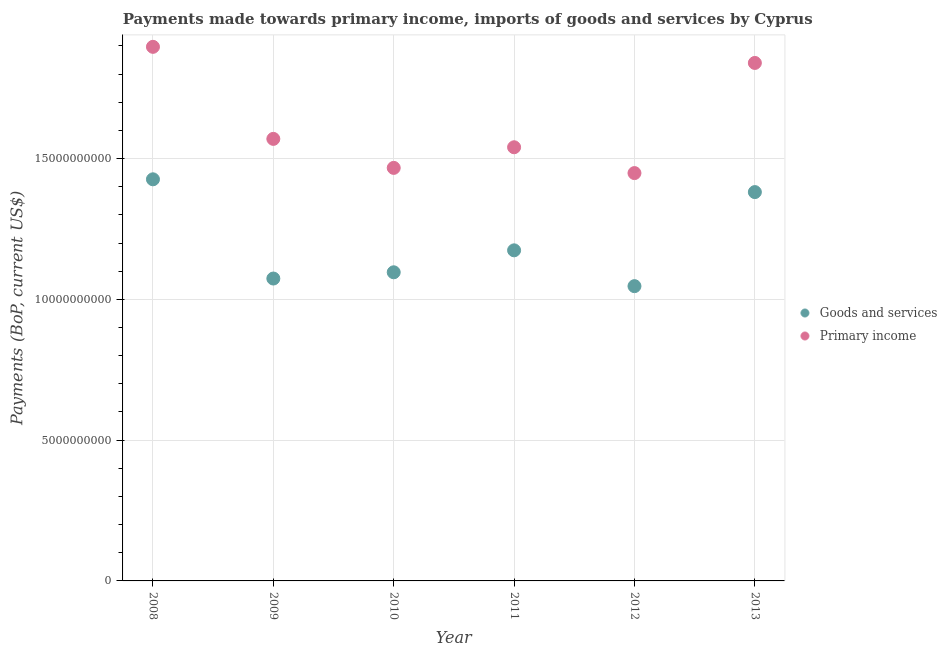How many different coloured dotlines are there?
Ensure brevity in your answer.  2. Is the number of dotlines equal to the number of legend labels?
Your response must be concise. Yes. What is the payments made towards goods and services in 2008?
Offer a terse response. 1.43e+1. Across all years, what is the maximum payments made towards goods and services?
Make the answer very short. 1.43e+1. Across all years, what is the minimum payments made towards goods and services?
Give a very brief answer. 1.05e+1. What is the total payments made towards goods and services in the graph?
Your answer should be compact. 7.20e+1. What is the difference between the payments made towards primary income in 2010 and that in 2012?
Ensure brevity in your answer.  1.85e+08. What is the difference between the payments made towards goods and services in 2010 and the payments made towards primary income in 2012?
Ensure brevity in your answer.  -3.52e+09. What is the average payments made towards goods and services per year?
Offer a very short reply. 1.20e+1. In the year 2010, what is the difference between the payments made towards goods and services and payments made towards primary income?
Offer a terse response. -3.71e+09. In how many years, is the payments made towards primary income greater than 18000000000 US$?
Offer a terse response. 2. What is the ratio of the payments made towards goods and services in 2011 to that in 2013?
Provide a short and direct response. 0.85. Is the payments made towards goods and services in 2008 less than that in 2011?
Offer a terse response. No. What is the difference between the highest and the second highest payments made towards primary income?
Provide a succinct answer. 5.72e+08. What is the difference between the highest and the lowest payments made towards goods and services?
Offer a very short reply. 3.79e+09. In how many years, is the payments made towards goods and services greater than the average payments made towards goods and services taken over all years?
Provide a succinct answer. 2. Is the payments made towards primary income strictly greater than the payments made towards goods and services over the years?
Make the answer very short. Yes. What is the difference between two consecutive major ticks on the Y-axis?
Offer a terse response. 5.00e+09. Are the values on the major ticks of Y-axis written in scientific E-notation?
Your answer should be very brief. No. Where does the legend appear in the graph?
Your response must be concise. Center right. How many legend labels are there?
Make the answer very short. 2. How are the legend labels stacked?
Your response must be concise. Vertical. What is the title of the graph?
Your response must be concise. Payments made towards primary income, imports of goods and services by Cyprus. What is the label or title of the Y-axis?
Ensure brevity in your answer.  Payments (BoP, current US$). What is the Payments (BoP, current US$) of Goods and services in 2008?
Give a very brief answer. 1.43e+1. What is the Payments (BoP, current US$) in Primary income in 2008?
Keep it short and to the point. 1.90e+1. What is the Payments (BoP, current US$) in Goods and services in 2009?
Give a very brief answer. 1.07e+1. What is the Payments (BoP, current US$) in Primary income in 2009?
Make the answer very short. 1.57e+1. What is the Payments (BoP, current US$) of Goods and services in 2010?
Offer a very short reply. 1.10e+1. What is the Payments (BoP, current US$) of Primary income in 2010?
Ensure brevity in your answer.  1.47e+1. What is the Payments (BoP, current US$) of Goods and services in 2011?
Your response must be concise. 1.17e+1. What is the Payments (BoP, current US$) of Primary income in 2011?
Keep it short and to the point. 1.54e+1. What is the Payments (BoP, current US$) of Goods and services in 2012?
Give a very brief answer. 1.05e+1. What is the Payments (BoP, current US$) in Primary income in 2012?
Offer a terse response. 1.45e+1. What is the Payments (BoP, current US$) in Goods and services in 2013?
Provide a succinct answer. 1.38e+1. What is the Payments (BoP, current US$) of Primary income in 2013?
Your answer should be compact. 1.84e+1. Across all years, what is the maximum Payments (BoP, current US$) in Goods and services?
Ensure brevity in your answer.  1.43e+1. Across all years, what is the maximum Payments (BoP, current US$) of Primary income?
Provide a short and direct response. 1.90e+1. Across all years, what is the minimum Payments (BoP, current US$) of Goods and services?
Offer a terse response. 1.05e+1. Across all years, what is the minimum Payments (BoP, current US$) in Primary income?
Your response must be concise. 1.45e+1. What is the total Payments (BoP, current US$) in Goods and services in the graph?
Your response must be concise. 7.20e+1. What is the total Payments (BoP, current US$) in Primary income in the graph?
Your answer should be compact. 9.76e+1. What is the difference between the Payments (BoP, current US$) in Goods and services in 2008 and that in 2009?
Give a very brief answer. 3.52e+09. What is the difference between the Payments (BoP, current US$) in Primary income in 2008 and that in 2009?
Your answer should be very brief. 3.27e+09. What is the difference between the Payments (BoP, current US$) in Goods and services in 2008 and that in 2010?
Provide a succinct answer. 3.30e+09. What is the difference between the Payments (BoP, current US$) in Primary income in 2008 and that in 2010?
Offer a very short reply. 4.30e+09. What is the difference between the Payments (BoP, current US$) of Goods and services in 2008 and that in 2011?
Your response must be concise. 2.52e+09. What is the difference between the Payments (BoP, current US$) of Primary income in 2008 and that in 2011?
Offer a terse response. 3.57e+09. What is the difference between the Payments (BoP, current US$) in Goods and services in 2008 and that in 2012?
Provide a short and direct response. 3.79e+09. What is the difference between the Payments (BoP, current US$) in Primary income in 2008 and that in 2012?
Your answer should be very brief. 4.48e+09. What is the difference between the Payments (BoP, current US$) in Goods and services in 2008 and that in 2013?
Keep it short and to the point. 4.54e+08. What is the difference between the Payments (BoP, current US$) of Primary income in 2008 and that in 2013?
Make the answer very short. 5.72e+08. What is the difference between the Payments (BoP, current US$) of Goods and services in 2009 and that in 2010?
Your answer should be compact. -2.22e+08. What is the difference between the Payments (BoP, current US$) of Primary income in 2009 and that in 2010?
Give a very brief answer. 1.03e+09. What is the difference between the Payments (BoP, current US$) of Goods and services in 2009 and that in 2011?
Give a very brief answer. -1.00e+09. What is the difference between the Payments (BoP, current US$) in Primary income in 2009 and that in 2011?
Offer a terse response. 2.97e+08. What is the difference between the Payments (BoP, current US$) in Goods and services in 2009 and that in 2012?
Your answer should be compact. 2.70e+08. What is the difference between the Payments (BoP, current US$) in Primary income in 2009 and that in 2012?
Offer a terse response. 1.21e+09. What is the difference between the Payments (BoP, current US$) of Goods and services in 2009 and that in 2013?
Provide a succinct answer. -3.07e+09. What is the difference between the Payments (BoP, current US$) of Primary income in 2009 and that in 2013?
Provide a short and direct response. -2.70e+09. What is the difference between the Payments (BoP, current US$) in Goods and services in 2010 and that in 2011?
Keep it short and to the point. -7.80e+08. What is the difference between the Payments (BoP, current US$) of Primary income in 2010 and that in 2011?
Make the answer very short. -7.33e+08. What is the difference between the Payments (BoP, current US$) in Goods and services in 2010 and that in 2012?
Keep it short and to the point. 4.92e+08. What is the difference between the Payments (BoP, current US$) in Primary income in 2010 and that in 2012?
Provide a short and direct response. 1.85e+08. What is the difference between the Payments (BoP, current US$) in Goods and services in 2010 and that in 2013?
Your response must be concise. -2.85e+09. What is the difference between the Payments (BoP, current US$) in Primary income in 2010 and that in 2013?
Ensure brevity in your answer.  -3.73e+09. What is the difference between the Payments (BoP, current US$) of Goods and services in 2011 and that in 2012?
Give a very brief answer. 1.27e+09. What is the difference between the Payments (BoP, current US$) in Primary income in 2011 and that in 2012?
Offer a very short reply. 9.17e+08. What is the difference between the Payments (BoP, current US$) of Goods and services in 2011 and that in 2013?
Ensure brevity in your answer.  -2.07e+09. What is the difference between the Payments (BoP, current US$) in Primary income in 2011 and that in 2013?
Your answer should be compact. -2.99e+09. What is the difference between the Payments (BoP, current US$) in Goods and services in 2012 and that in 2013?
Offer a very short reply. -3.34e+09. What is the difference between the Payments (BoP, current US$) of Primary income in 2012 and that in 2013?
Provide a succinct answer. -3.91e+09. What is the difference between the Payments (BoP, current US$) of Goods and services in 2008 and the Payments (BoP, current US$) of Primary income in 2009?
Your answer should be very brief. -1.44e+09. What is the difference between the Payments (BoP, current US$) in Goods and services in 2008 and the Payments (BoP, current US$) in Primary income in 2010?
Provide a succinct answer. -4.06e+08. What is the difference between the Payments (BoP, current US$) of Goods and services in 2008 and the Payments (BoP, current US$) of Primary income in 2011?
Your answer should be very brief. -1.14e+09. What is the difference between the Payments (BoP, current US$) of Goods and services in 2008 and the Payments (BoP, current US$) of Primary income in 2012?
Your response must be concise. -2.21e+08. What is the difference between the Payments (BoP, current US$) of Goods and services in 2008 and the Payments (BoP, current US$) of Primary income in 2013?
Offer a terse response. -4.13e+09. What is the difference between the Payments (BoP, current US$) in Goods and services in 2009 and the Payments (BoP, current US$) in Primary income in 2010?
Give a very brief answer. -3.93e+09. What is the difference between the Payments (BoP, current US$) of Goods and services in 2009 and the Payments (BoP, current US$) of Primary income in 2011?
Offer a terse response. -4.66e+09. What is the difference between the Payments (BoP, current US$) of Goods and services in 2009 and the Payments (BoP, current US$) of Primary income in 2012?
Keep it short and to the point. -3.75e+09. What is the difference between the Payments (BoP, current US$) in Goods and services in 2009 and the Payments (BoP, current US$) in Primary income in 2013?
Provide a short and direct response. -7.66e+09. What is the difference between the Payments (BoP, current US$) of Goods and services in 2010 and the Payments (BoP, current US$) of Primary income in 2011?
Provide a succinct answer. -4.44e+09. What is the difference between the Payments (BoP, current US$) of Goods and services in 2010 and the Payments (BoP, current US$) of Primary income in 2012?
Keep it short and to the point. -3.52e+09. What is the difference between the Payments (BoP, current US$) in Goods and services in 2010 and the Payments (BoP, current US$) in Primary income in 2013?
Your answer should be compact. -7.44e+09. What is the difference between the Payments (BoP, current US$) in Goods and services in 2011 and the Payments (BoP, current US$) in Primary income in 2012?
Give a very brief answer. -2.74e+09. What is the difference between the Payments (BoP, current US$) of Goods and services in 2011 and the Payments (BoP, current US$) of Primary income in 2013?
Make the answer very short. -6.66e+09. What is the difference between the Payments (BoP, current US$) in Goods and services in 2012 and the Payments (BoP, current US$) in Primary income in 2013?
Give a very brief answer. -7.93e+09. What is the average Payments (BoP, current US$) of Goods and services per year?
Your response must be concise. 1.20e+1. What is the average Payments (BoP, current US$) of Primary income per year?
Offer a very short reply. 1.63e+1. In the year 2008, what is the difference between the Payments (BoP, current US$) in Goods and services and Payments (BoP, current US$) in Primary income?
Offer a very short reply. -4.70e+09. In the year 2009, what is the difference between the Payments (BoP, current US$) in Goods and services and Payments (BoP, current US$) in Primary income?
Offer a very short reply. -4.96e+09. In the year 2010, what is the difference between the Payments (BoP, current US$) in Goods and services and Payments (BoP, current US$) in Primary income?
Offer a very short reply. -3.71e+09. In the year 2011, what is the difference between the Payments (BoP, current US$) in Goods and services and Payments (BoP, current US$) in Primary income?
Your response must be concise. -3.66e+09. In the year 2012, what is the difference between the Payments (BoP, current US$) of Goods and services and Payments (BoP, current US$) of Primary income?
Offer a very short reply. -4.02e+09. In the year 2013, what is the difference between the Payments (BoP, current US$) in Goods and services and Payments (BoP, current US$) in Primary income?
Offer a very short reply. -4.59e+09. What is the ratio of the Payments (BoP, current US$) in Goods and services in 2008 to that in 2009?
Offer a terse response. 1.33. What is the ratio of the Payments (BoP, current US$) of Primary income in 2008 to that in 2009?
Offer a very short reply. 1.21. What is the ratio of the Payments (BoP, current US$) in Goods and services in 2008 to that in 2010?
Your response must be concise. 1.3. What is the ratio of the Payments (BoP, current US$) of Primary income in 2008 to that in 2010?
Ensure brevity in your answer.  1.29. What is the ratio of the Payments (BoP, current US$) of Goods and services in 2008 to that in 2011?
Offer a very short reply. 1.21. What is the ratio of the Payments (BoP, current US$) of Primary income in 2008 to that in 2011?
Ensure brevity in your answer.  1.23. What is the ratio of the Payments (BoP, current US$) in Goods and services in 2008 to that in 2012?
Your response must be concise. 1.36. What is the ratio of the Payments (BoP, current US$) of Primary income in 2008 to that in 2012?
Give a very brief answer. 1.31. What is the ratio of the Payments (BoP, current US$) of Goods and services in 2008 to that in 2013?
Your response must be concise. 1.03. What is the ratio of the Payments (BoP, current US$) of Primary income in 2008 to that in 2013?
Ensure brevity in your answer.  1.03. What is the ratio of the Payments (BoP, current US$) in Goods and services in 2009 to that in 2010?
Provide a short and direct response. 0.98. What is the ratio of the Payments (BoP, current US$) of Primary income in 2009 to that in 2010?
Give a very brief answer. 1.07. What is the ratio of the Payments (BoP, current US$) of Goods and services in 2009 to that in 2011?
Give a very brief answer. 0.91. What is the ratio of the Payments (BoP, current US$) in Primary income in 2009 to that in 2011?
Make the answer very short. 1.02. What is the ratio of the Payments (BoP, current US$) in Goods and services in 2009 to that in 2012?
Keep it short and to the point. 1.03. What is the ratio of the Payments (BoP, current US$) of Primary income in 2009 to that in 2012?
Your response must be concise. 1.08. What is the ratio of the Payments (BoP, current US$) of Goods and services in 2009 to that in 2013?
Offer a terse response. 0.78. What is the ratio of the Payments (BoP, current US$) of Primary income in 2009 to that in 2013?
Your answer should be compact. 0.85. What is the ratio of the Payments (BoP, current US$) in Goods and services in 2010 to that in 2011?
Make the answer very short. 0.93. What is the ratio of the Payments (BoP, current US$) in Primary income in 2010 to that in 2011?
Make the answer very short. 0.95. What is the ratio of the Payments (BoP, current US$) of Goods and services in 2010 to that in 2012?
Ensure brevity in your answer.  1.05. What is the ratio of the Payments (BoP, current US$) in Primary income in 2010 to that in 2012?
Make the answer very short. 1.01. What is the ratio of the Payments (BoP, current US$) of Goods and services in 2010 to that in 2013?
Give a very brief answer. 0.79. What is the ratio of the Payments (BoP, current US$) of Primary income in 2010 to that in 2013?
Give a very brief answer. 0.8. What is the ratio of the Payments (BoP, current US$) of Goods and services in 2011 to that in 2012?
Provide a succinct answer. 1.12. What is the ratio of the Payments (BoP, current US$) of Primary income in 2011 to that in 2012?
Ensure brevity in your answer.  1.06. What is the ratio of the Payments (BoP, current US$) in Goods and services in 2011 to that in 2013?
Provide a succinct answer. 0.85. What is the ratio of the Payments (BoP, current US$) in Primary income in 2011 to that in 2013?
Keep it short and to the point. 0.84. What is the ratio of the Payments (BoP, current US$) of Goods and services in 2012 to that in 2013?
Your response must be concise. 0.76. What is the ratio of the Payments (BoP, current US$) in Primary income in 2012 to that in 2013?
Your answer should be very brief. 0.79. What is the difference between the highest and the second highest Payments (BoP, current US$) of Goods and services?
Your answer should be compact. 4.54e+08. What is the difference between the highest and the second highest Payments (BoP, current US$) of Primary income?
Your answer should be compact. 5.72e+08. What is the difference between the highest and the lowest Payments (BoP, current US$) of Goods and services?
Give a very brief answer. 3.79e+09. What is the difference between the highest and the lowest Payments (BoP, current US$) in Primary income?
Your answer should be very brief. 4.48e+09. 